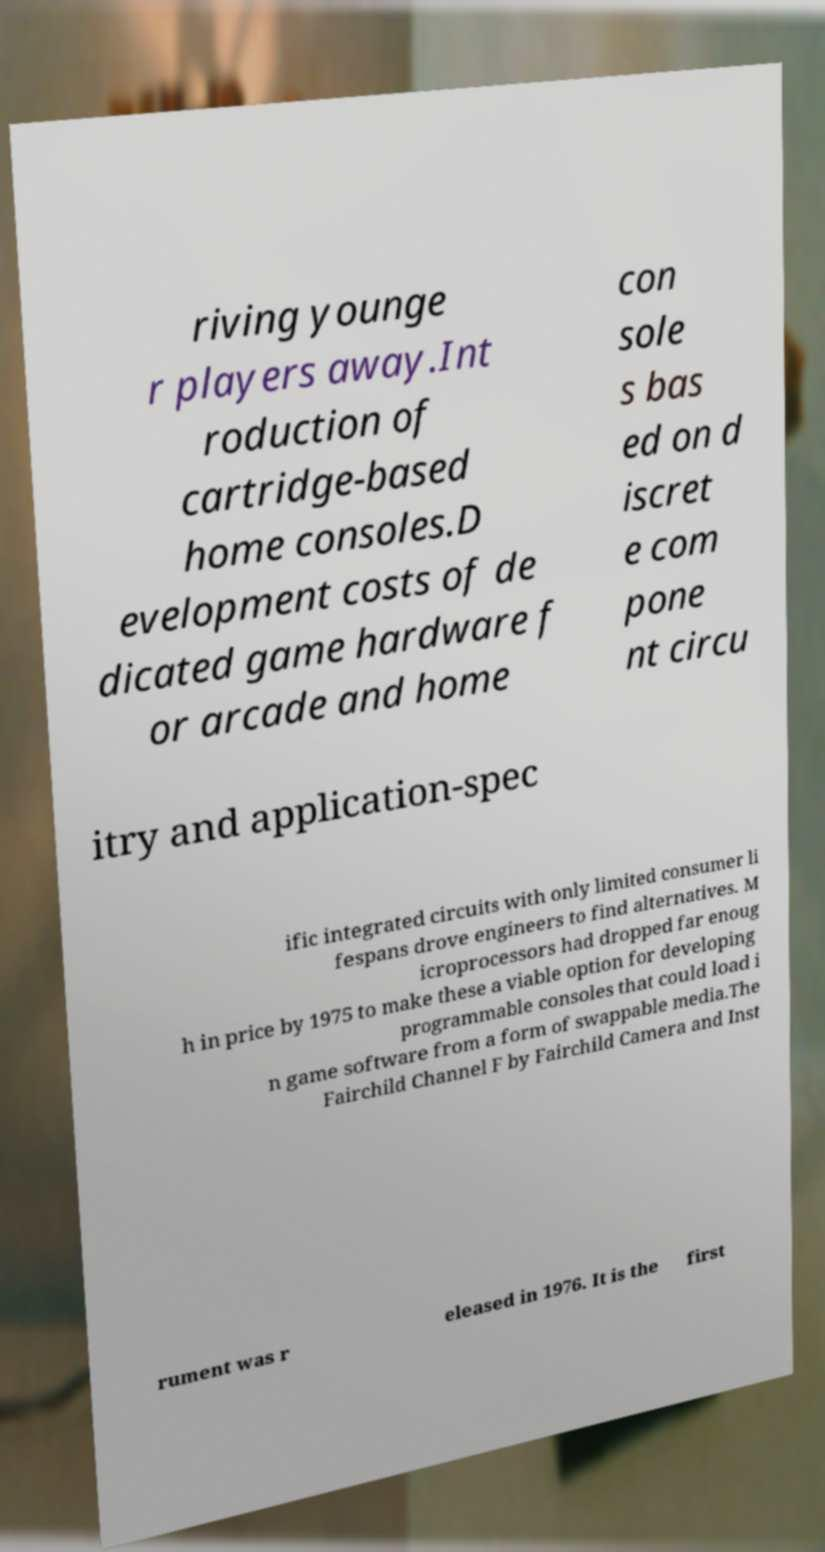I need the written content from this picture converted into text. Can you do that? riving younge r players away.Int roduction of cartridge-based home consoles.D evelopment costs of de dicated game hardware f or arcade and home con sole s bas ed on d iscret e com pone nt circu itry and application-spec ific integrated circuits with only limited consumer li fespans drove engineers to find alternatives. M icroprocessors had dropped far enoug h in price by 1975 to make these a viable option for developing programmable consoles that could load i n game software from a form of swappable media.The Fairchild Channel F by Fairchild Camera and Inst rument was r eleased in 1976. It is the first 